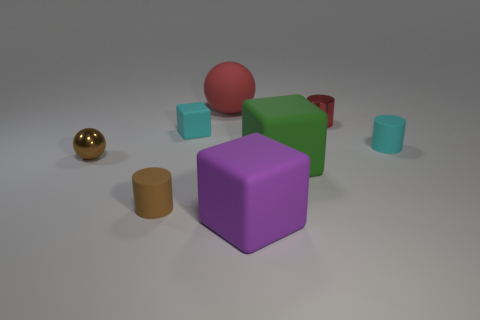Do the cyan rubber cube and the green matte cube have the same size?
Provide a succinct answer. No. What number of objects are big objects that are in front of the tiny red metallic cylinder or spheres?
Your response must be concise. 4. Do the red shiny object and the large purple rubber object have the same shape?
Your answer should be compact. No. What number of other objects are the same size as the green object?
Your answer should be compact. 2. What color is the small metallic ball?
Provide a succinct answer. Brown. What number of small objects are either blue matte cylinders or cyan matte cubes?
Provide a short and direct response. 1. Is the size of the matte cylinder to the left of the small rubber cube the same as the cube that is in front of the green block?
Ensure brevity in your answer.  No. The green rubber object that is the same shape as the purple matte thing is what size?
Offer a very short reply. Large. Is the number of tiny objects in front of the cyan rubber cylinder greater than the number of small brown spheres to the right of the tiny red object?
Offer a terse response. Yes. The tiny thing that is both in front of the tiny block and on the right side of the brown matte object is made of what material?
Your answer should be compact. Rubber. 